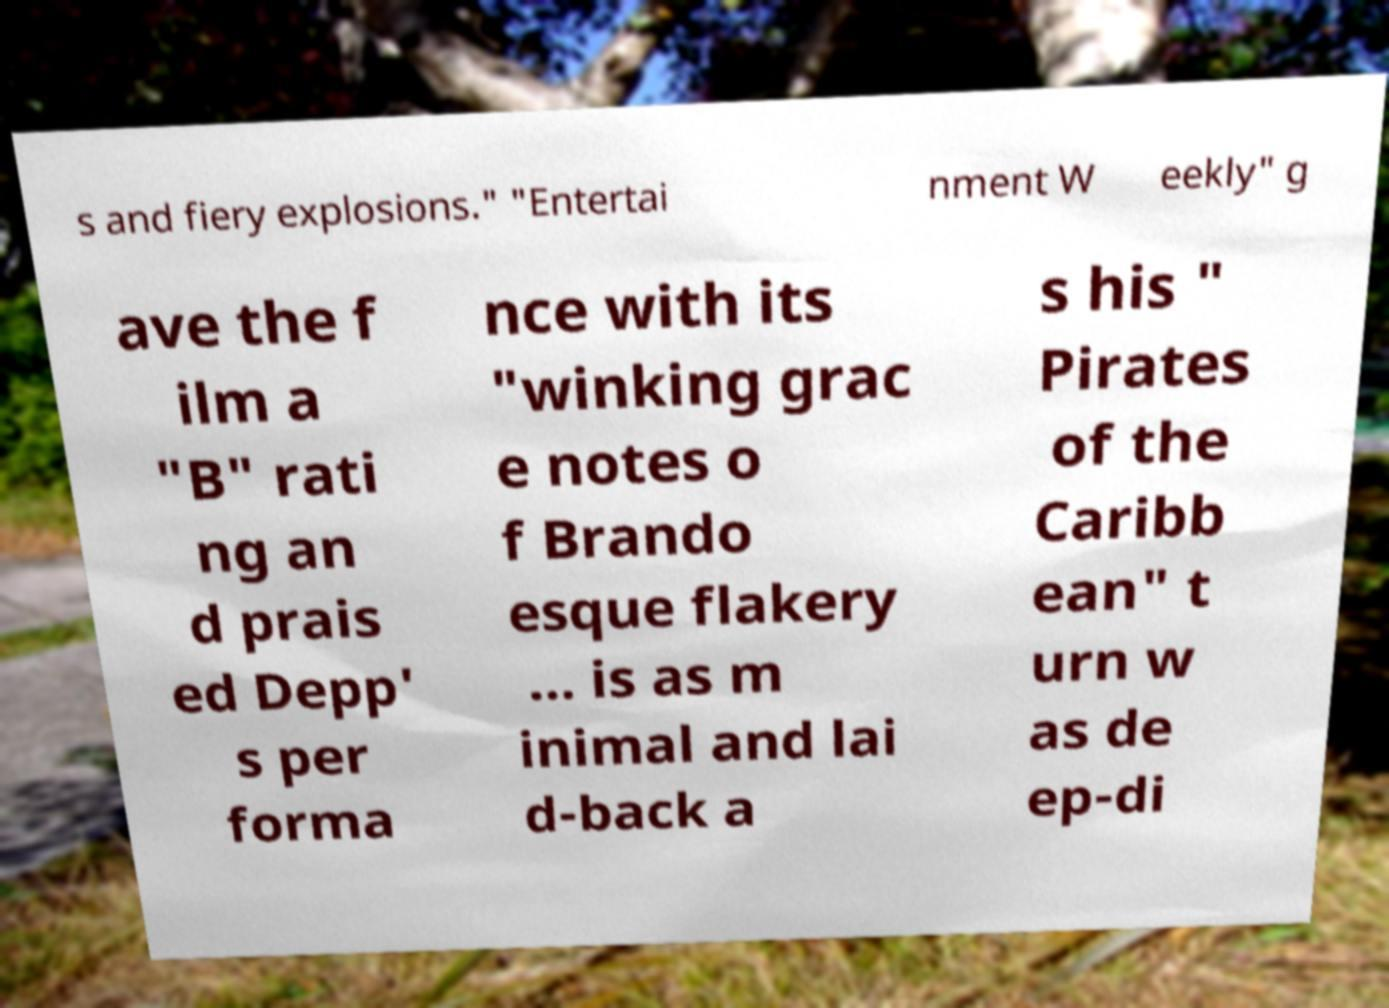Please read and relay the text visible in this image. What does it say? s and fiery explosions." "Entertai nment W eekly" g ave the f ilm a "B" rati ng an d prais ed Depp' s per forma nce with its "winking grac e notes o f Brando esque flakery ... is as m inimal and lai d-back a s his " Pirates of the Caribb ean" t urn w as de ep-di 